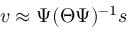<formula> <loc_0><loc_0><loc_500><loc_500>v \approx \Psi ( \Theta \Psi ) ^ { - 1 } s</formula> 